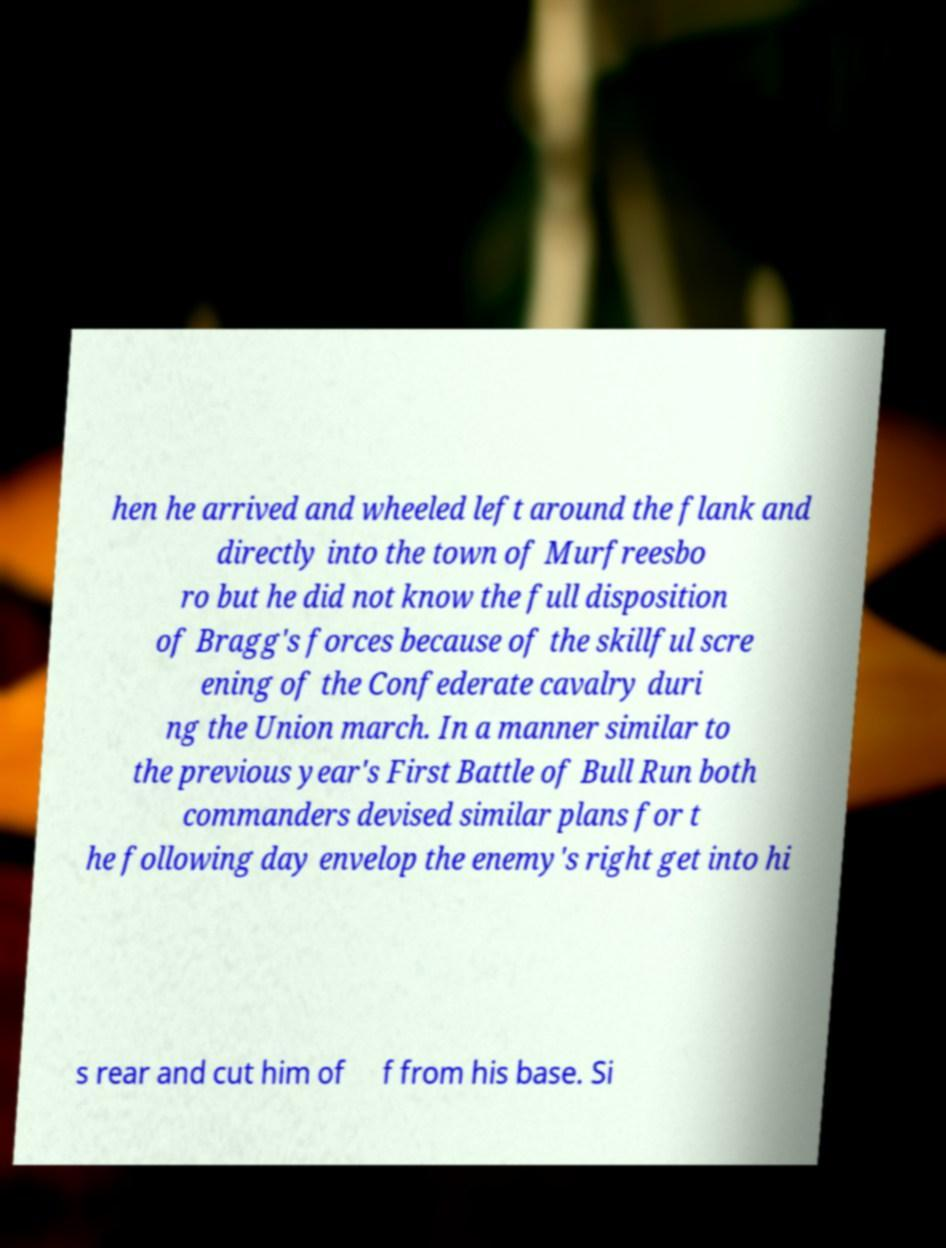Could you extract and type out the text from this image? hen he arrived and wheeled left around the flank and directly into the town of Murfreesbo ro but he did not know the full disposition of Bragg's forces because of the skillful scre ening of the Confederate cavalry duri ng the Union march. In a manner similar to the previous year's First Battle of Bull Run both commanders devised similar plans for t he following day envelop the enemy's right get into hi s rear and cut him of f from his base. Si 